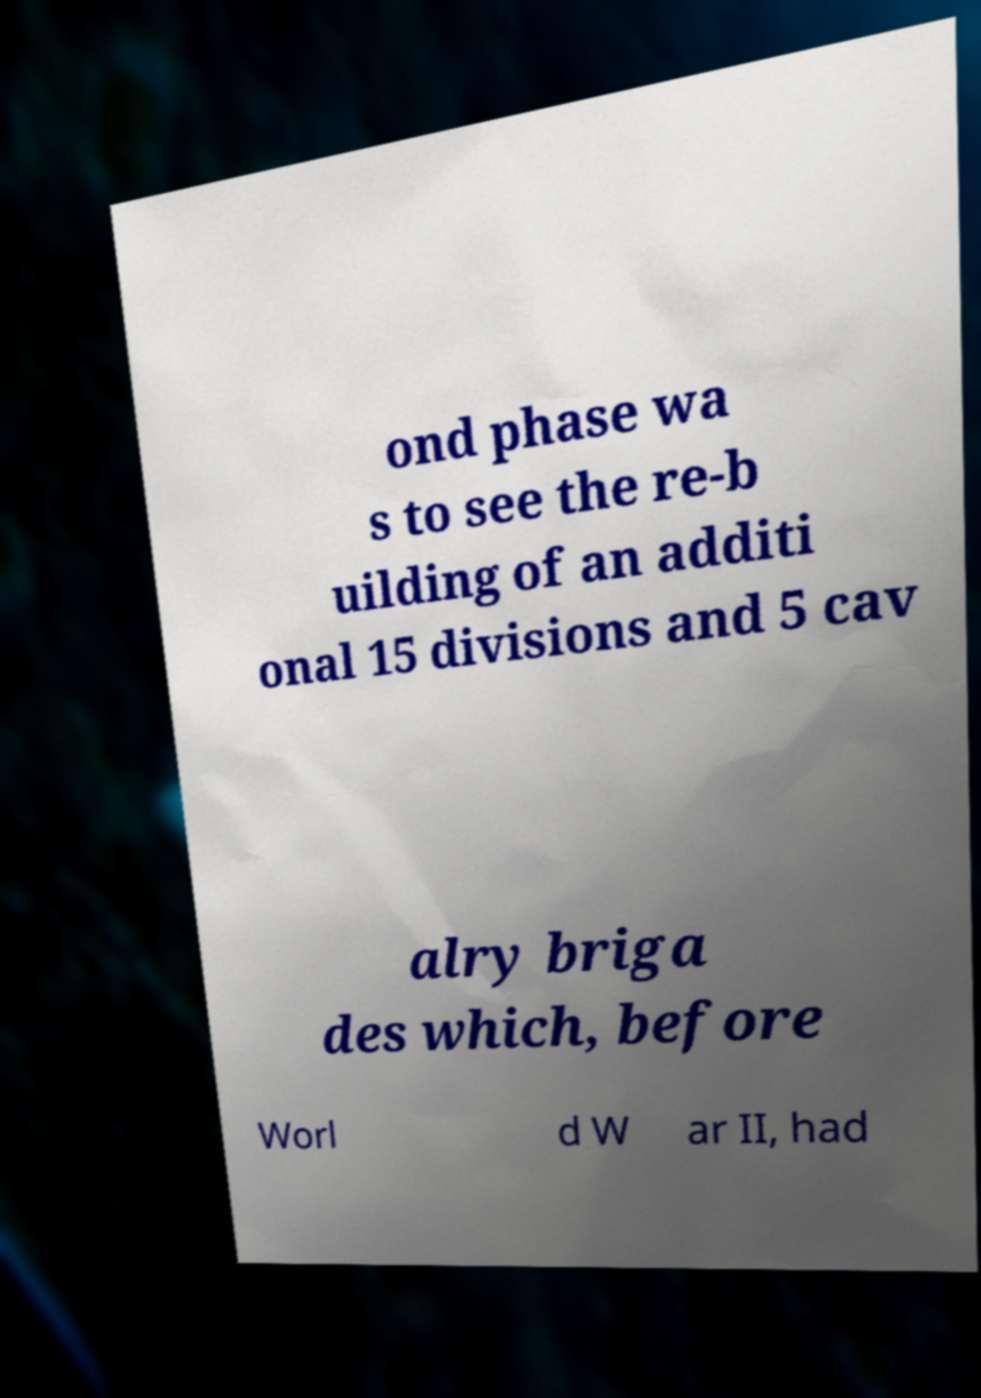For documentation purposes, I need the text within this image transcribed. Could you provide that? ond phase wa s to see the re-b uilding of an additi onal 15 divisions and 5 cav alry briga des which, before Worl d W ar II, had 